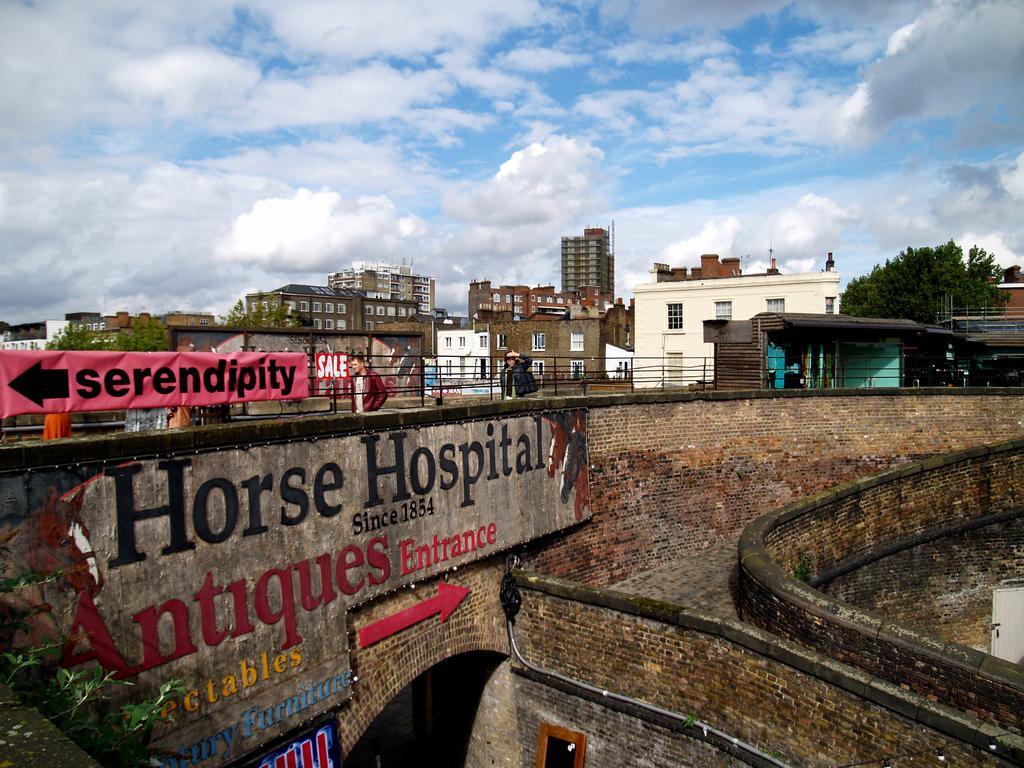Please provide a concise description of this image. This is an outside view. At the bottom of this image there is a bridge. On the left side there is a board attached to the bridge. On this board I can see some text. At the top of the bridge there is a railing and a board is attached to it. Behind the railing there are few people. In the background there are many buildings and trees. At the top of the image I can see the sky and clouds. 